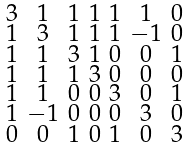<formula> <loc_0><loc_0><loc_500><loc_500>\begin{smallmatrix} 3 & 1 & 1 & 1 & 1 & 1 & 0 \\ 1 & 3 & 1 & 1 & 1 & - 1 & 0 \\ 1 & 1 & 3 & 1 & 0 & 0 & 1 \\ 1 & 1 & 1 & 3 & 0 & 0 & 0 \\ 1 & 1 & 0 & 0 & 3 & 0 & 1 \\ 1 & - 1 & 0 & 0 & 0 & 3 & 0 \\ 0 & 0 & 1 & 0 & 1 & 0 & 3 \end{smallmatrix}</formula> 